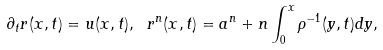Convert formula to latex. <formula><loc_0><loc_0><loc_500><loc_500>\partial _ { t } r ( x , t ) = u ( x , t ) , \ r ^ { n } ( x , t ) = a ^ { n } + n \int _ { 0 } ^ { x } \rho ^ { - 1 } ( y , t ) d y ,</formula> 